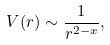<formula> <loc_0><loc_0><loc_500><loc_500>V ( r ) \sim \frac { 1 } { r ^ { 2 - x } } ,</formula> 